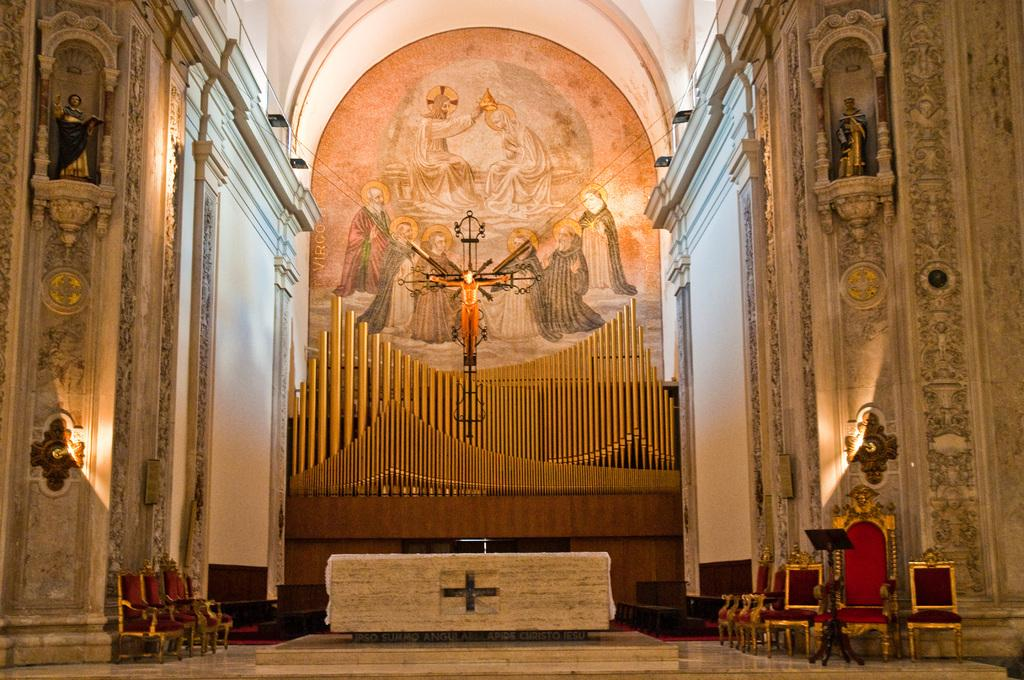What type of building is depicted in the image? The image is of the inside of a church. What can be seen in the middle of the church? There is a statue of Jesus Christ in the middle of the image. Where are the chairs located in the image? The chairs are on the right side of the image. What color are the chairs? The chairs are red in color. What type of chin is visible on the statue of Jesus Christ in the image? There is no chin visible on the statue of Jesus Christ in the image, as it is a sculpture and does not have a chin. 